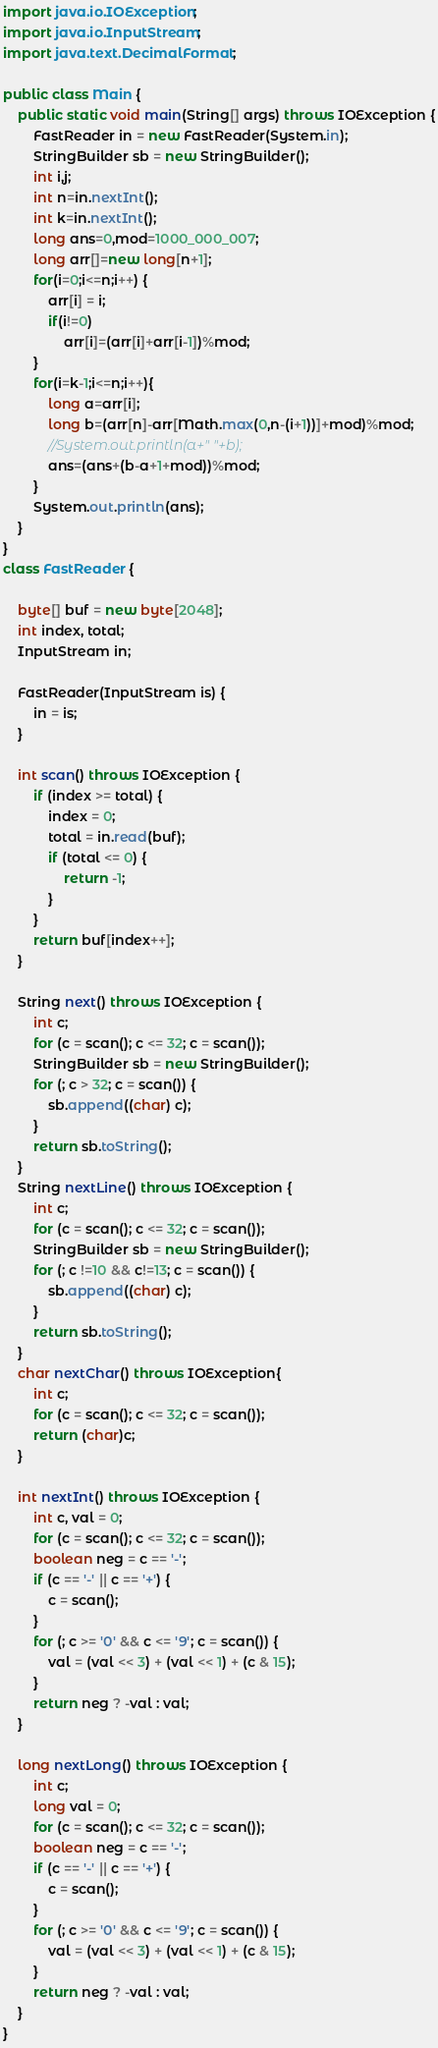Convert code to text. <code><loc_0><loc_0><loc_500><loc_500><_Java_>import java.io.IOException;
import java.io.InputStream;
import java.text.DecimalFormat;

public class Main {
    public static void main(String[] args) throws IOException {
        FastReader in = new FastReader(System.in);
        StringBuilder sb = new StringBuilder();
        int i,j;
        int n=in.nextInt();
        int k=in.nextInt();
        long ans=0,mod=1000_000_007;
        long arr[]=new long[n+1];
        for(i=0;i<=n;i++) {
            arr[i] = i;
            if(i!=0)
                arr[i]=(arr[i]+arr[i-1])%mod;
        }
        for(i=k-1;i<=n;i++){
            long a=arr[i];
            long b=(arr[n]-arr[Math.max(0,n-(i+1))]+mod)%mod;
            //System.out.println(a+" "+b);
            ans=(ans+(b-a+1+mod))%mod;
        }
        System.out.println(ans);
    }
}
class FastReader {

    byte[] buf = new byte[2048];
    int index, total;
    InputStream in;

    FastReader(InputStream is) {
        in = is;
    }

    int scan() throws IOException {
        if (index >= total) {
            index = 0;
            total = in.read(buf);
            if (total <= 0) {
                return -1;
            }
        }
        return buf[index++];
    }

    String next() throws IOException {
        int c;
        for (c = scan(); c <= 32; c = scan());
        StringBuilder sb = new StringBuilder();
        for (; c > 32; c = scan()) {
            sb.append((char) c);
        }
        return sb.toString();
    }
    String nextLine() throws IOException {
        int c;
        for (c = scan(); c <= 32; c = scan());
        StringBuilder sb = new StringBuilder();
        for (; c !=10 && c!=13; c = scan()) {
            sb.append((char) c);
        }
        return sb.toString();
    }
    char nextChar() throws IOException{
        int c;
        for (c = scan(); c <= 32; c = scan());
        return (char)c;
    }

    int nextInt() throws IOException {
        int c, val = 0;
        for (c = scan(); c <= 32; c = scan());
        boolean neg = c == '-';
        if (c == '-' || c == '+') {
            c = scan();
        }
        for (; c >= '0' && c <= '9'; c = scan()) {
            val = (val << 3) + (val << 1) + (c & 15);
        }
        return neg ? -val : val;
    }

    long nextLong() throws IOException {
        int c;
        long val = 0;
        for (c = scan(); c <= 32; c = scan());
        boolean neg = c == '-';
        if (c == '-' || c == '+') {
            c = scan();
        }
        for (; c >= '0' && c <= '9'; c = scan()) {
            val = (val << 3) + (val << 1) + (c & 15);
        }
        return neg ? -val : val;
    }
}
</code> 